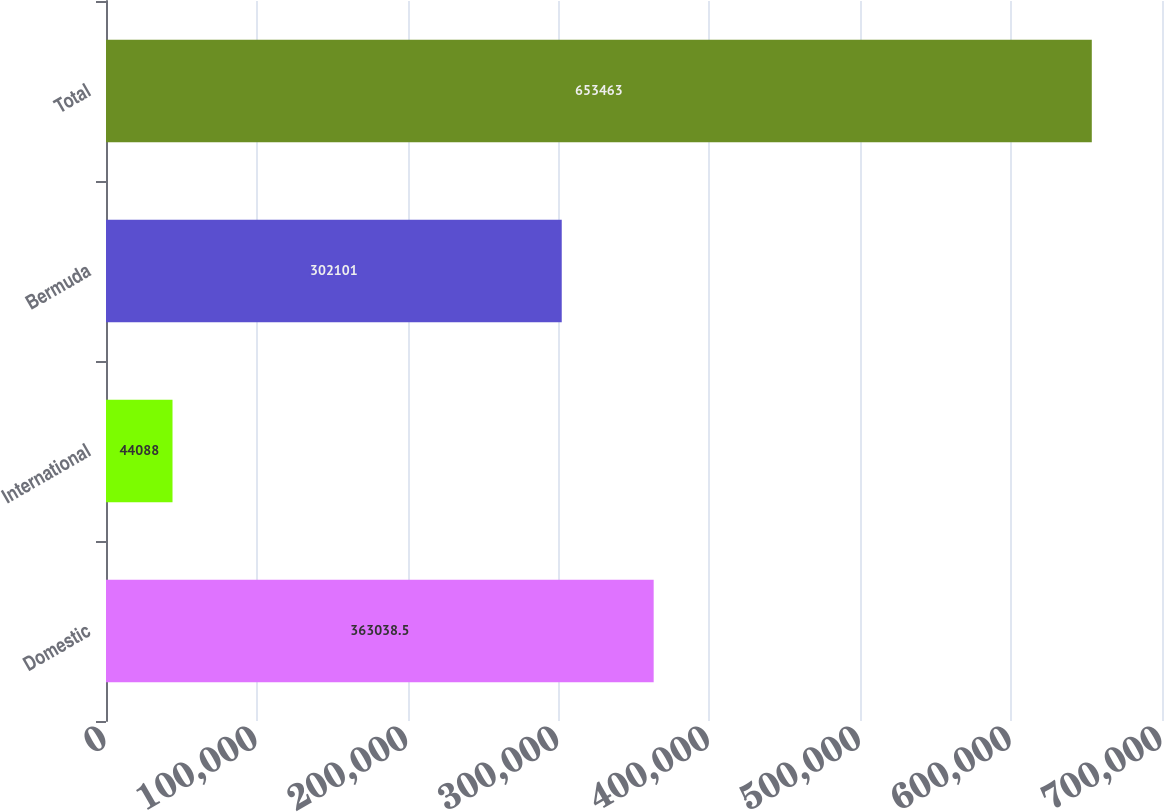Convert chart. <chart><loc_0><loc_0><loc_500><loc_500><bar_chart><fcel>Domestic<fcel>International<fcel>Bermuda<fcel>Total<nl><fcel>363038<fcel>44088<fcel>302101<fcel>653463<nl></chart> 